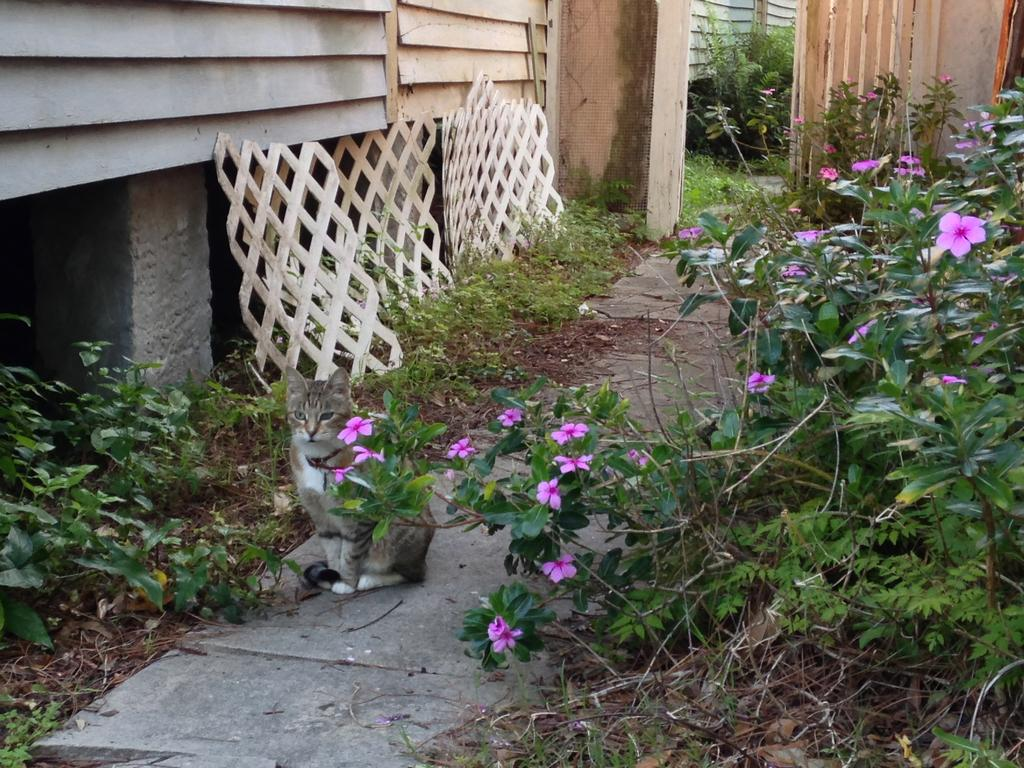What type of vegetation is on the right side of the image? There are flower plants on the right side of the image. What animal can be seen in the middle of the image? A cat is standing in the middle of a path in the image. What structure is located on the right side of the image? There appears to be a building on the right side of the image. What can be seen in the background of the image? There are plants visible in the background of the image. How many pies are being baked by the cat in the image? There are no pies present in the image, and the cat is not shown baking anything. What type of rose can be seen growing on the left side of the image? There is no rose visible in the image; only flower plants are mentioned on the right side. 